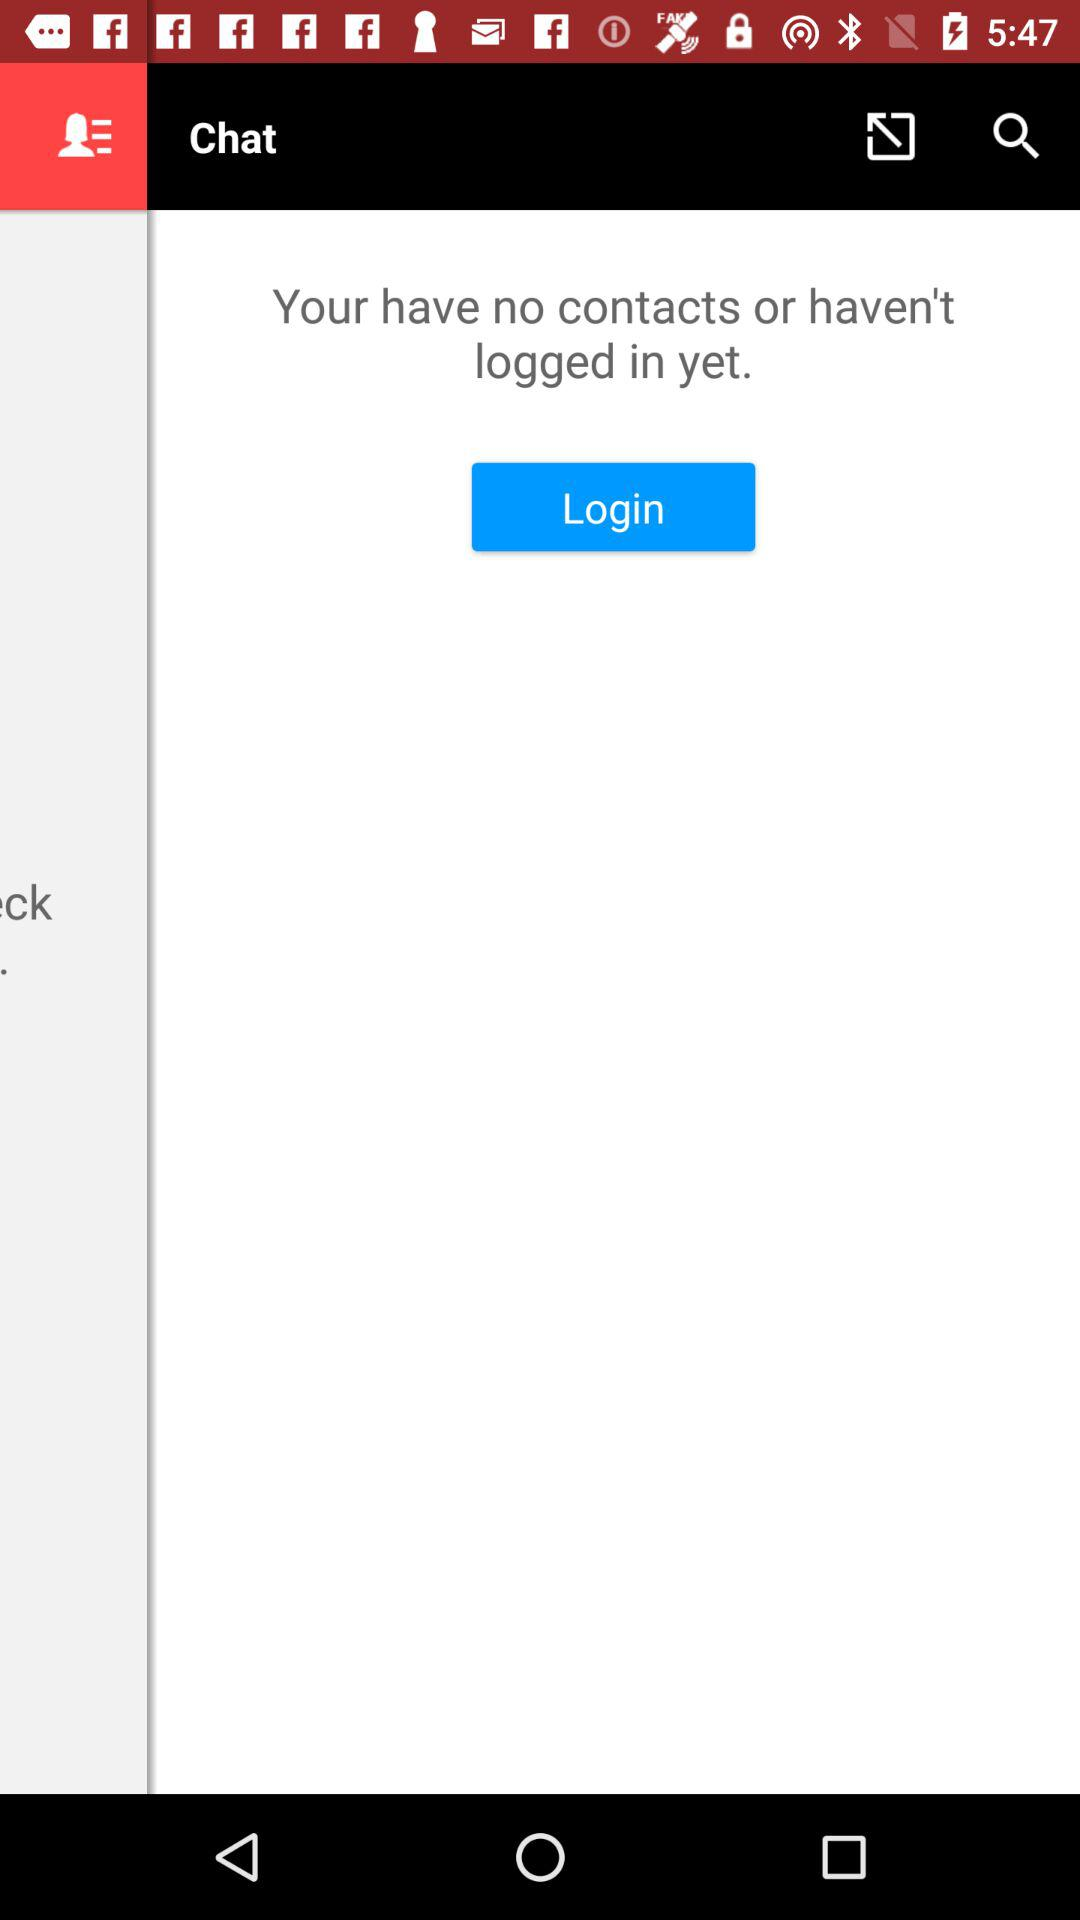How many contacts do we have? You have no contacts. 